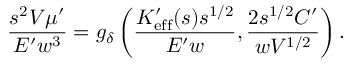<formula> <loc_0><loc_0><loc_500><loc_500>\frac { s ^ { 2 } V \mu ^ { \prime } } { E ^ { \prime } w ^ { 3 } } = g _ { \delta } \left ( \frac { K _ { e f f } ^ { \prime } ( s ) s ^ { 1 / 2 } } { E ^ { \prime } w } , \frac { 2 s ^ { 1 / 2 } C ^ { \prime } } { w V ^ { 1 / 2 } } \right ) .</formula> 